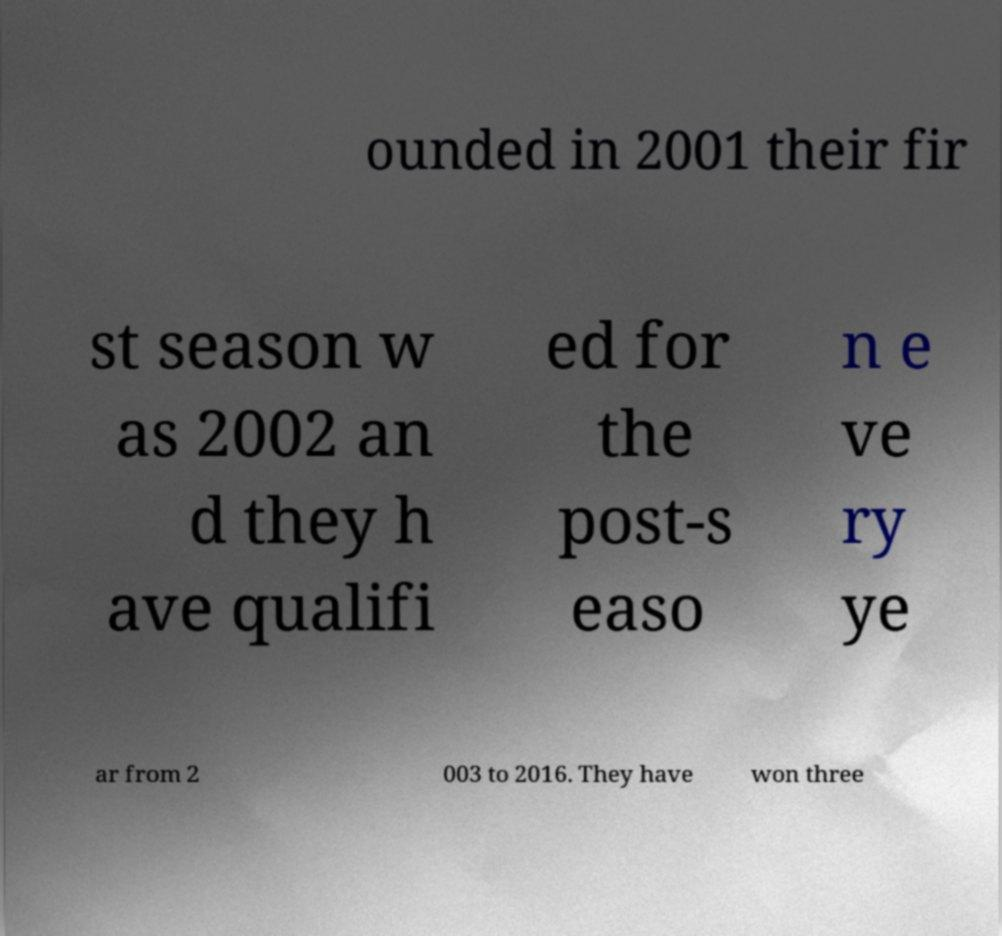For documentation purposes, I need the text within this image transcribed. Could you provide that? ounded in 2001 their fir st season w as 2002 an d they h ave qualifi ed for the post-s easo n e ve ry ye ar from 2 003 to 2016. They have won three 